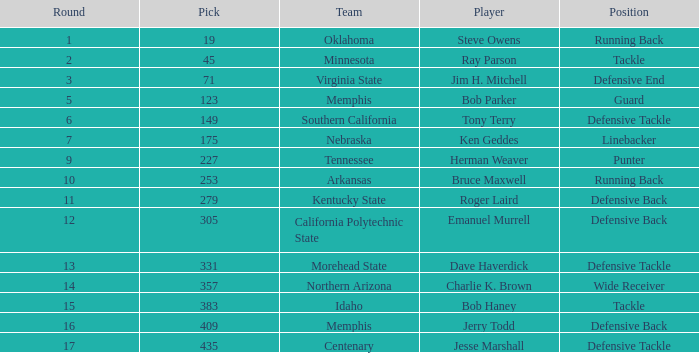What is the lowest pick of the defensive tackle player dave haverdick? 331.0. 